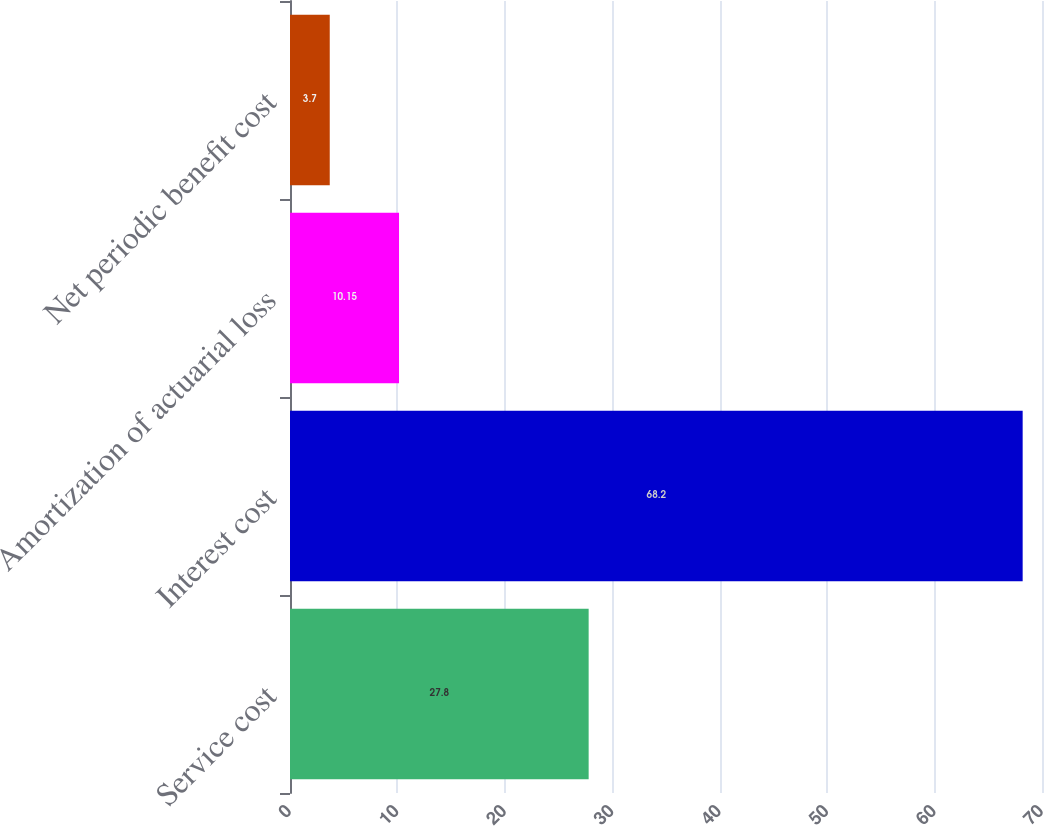Convert chart. <chart><loc_0><loc_0><loc_500><loc_500><bar_chart><fcel>Service cost<fcel>Interest cost<fcel>Amortization of actuarial loss<fcel>Net periodic benefit cost<nl><fcel>27.8<fcel>68.2<fcel>10.15<fcel>3.7<nl></chart> 